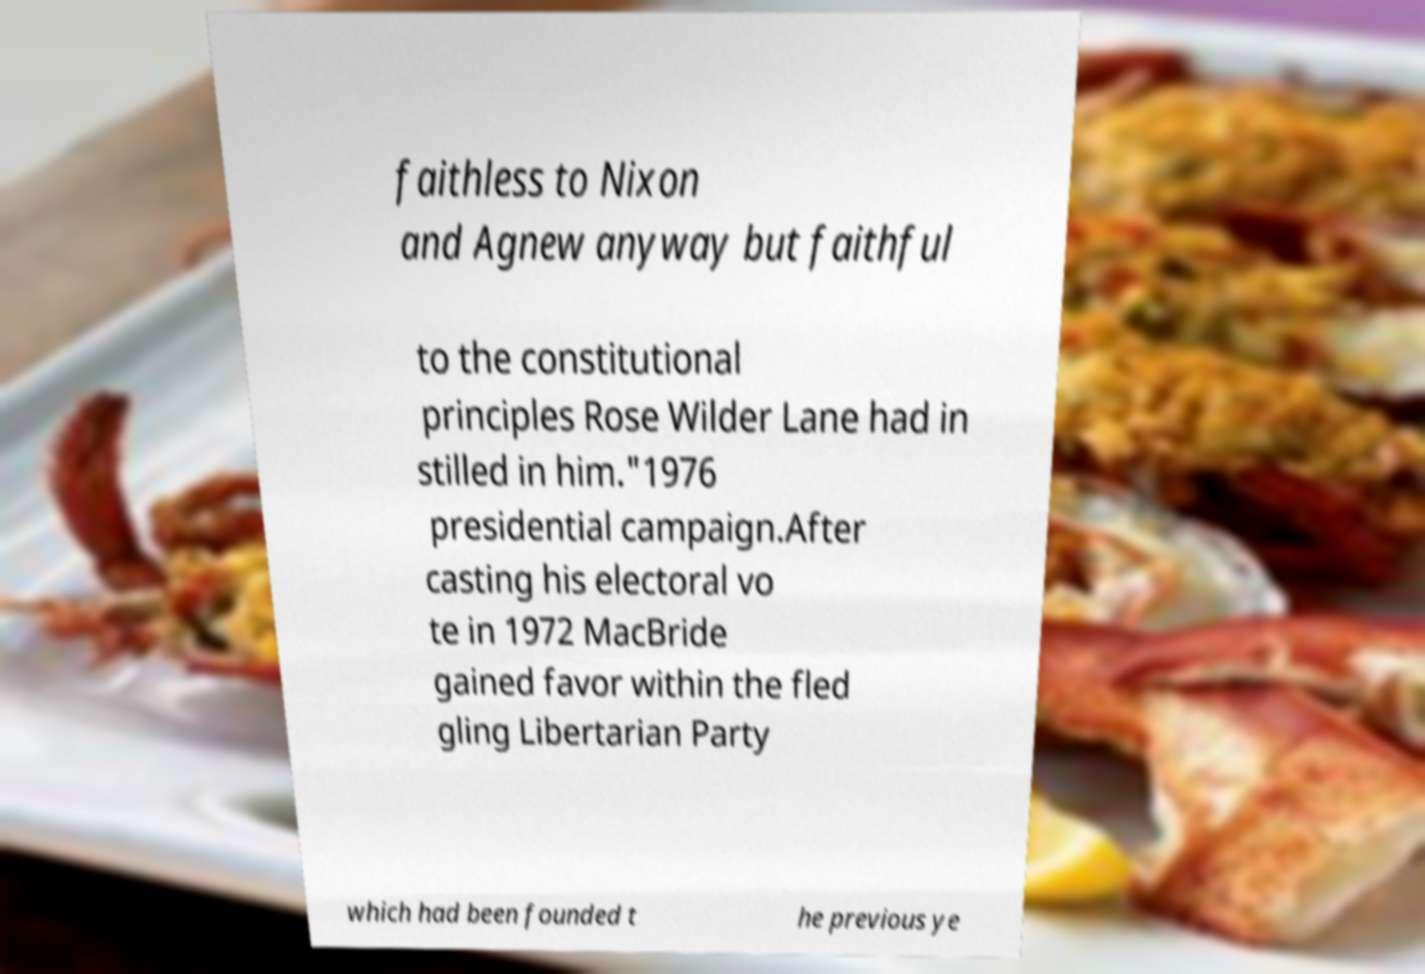Could you assist in decoding the text presented in this image and type it out clearly? faithless to Nixon and Agnew anyway but faithful to the constitutional principles Rose Wilder Lane had in stilled in him."1976 presidential campaign.After casting his electoral vo te in 1972 MacBride gained favor within the fled gling Libertarian Party which had been founded t he previous ye 